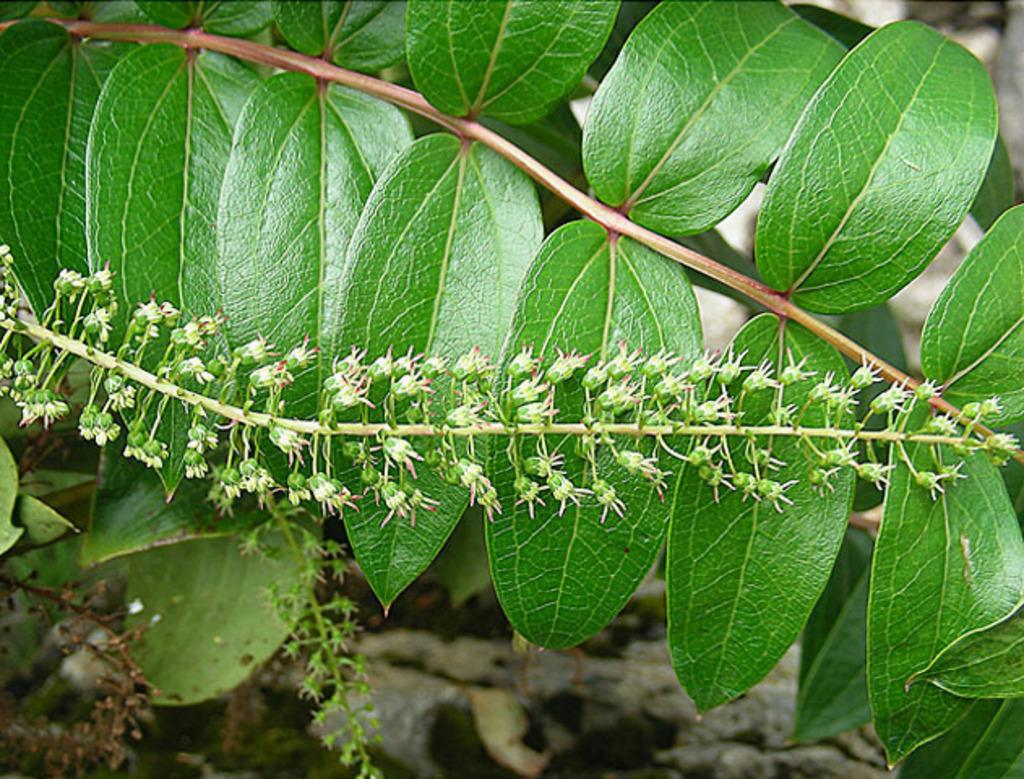What type of plant material can be seen in the image? There are leaves and flowers in the image. Can you describe the structure connecting the leaves and flowers? There is a stem in the image. What is the appearance of the background in the image? The background of the image is blurred. What type of soup can be seen in the image? There is no soup present in the image; it features leaves, flowers, and a stem. How does the beam of light affect the flowers in the image? There is no beam of light present in the image; it only shows leaves, flowers, and a stem with a blurred background. 